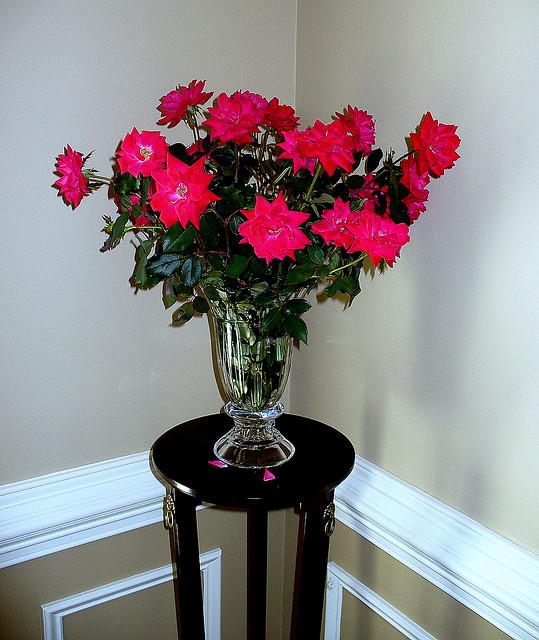Are these flowers being used as a dining room table centerpiece?
Write a very short answer. No. What flowers are these?
Write a very short answer. Roses. Have any petals fallen off?
Be succinct. Yes. What kind of flowers are these?
Give a very brief answer. Roses. 